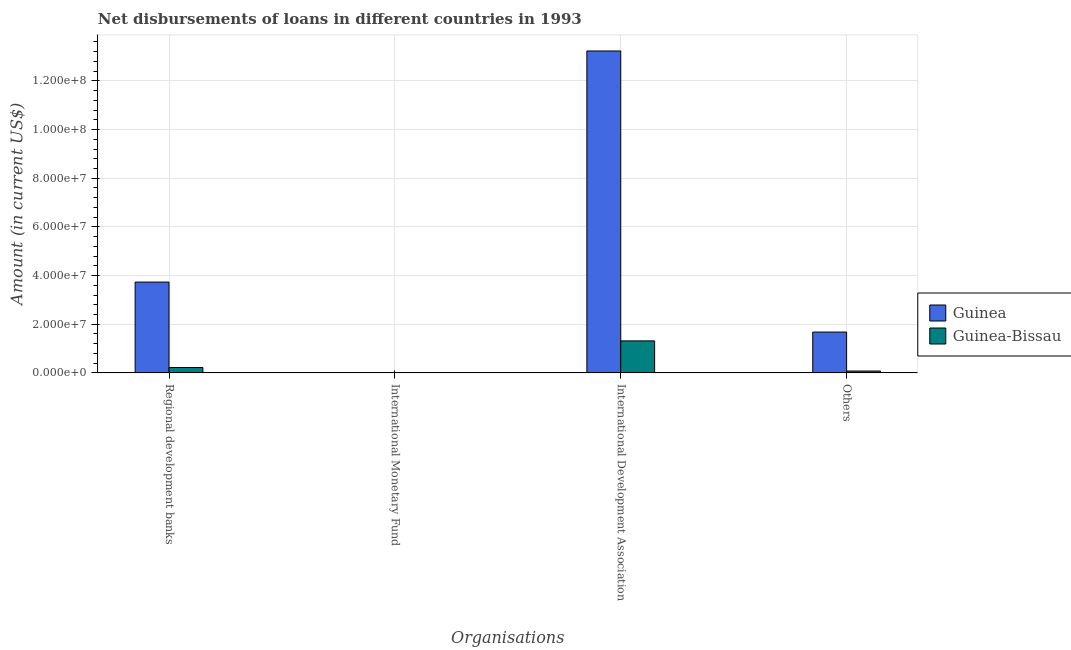How many different coloured bars are there?
Give a very brief answer. 2. How many bars are there on the 2nd tick from the left?
Provide a succinct answer. 0. What is the label of the 4th group of bars from the left?
Your response must be concise. Others. What is the amount of loan disimbursed by international development association in Guinea?
Offer a terse response. 1.32e+08. Across all countries, what is the maximum amount of loan disimbursed by regional development banks?
Your answer should be very brief. 3.73e+07. Across all countries, what is the minimum amount of loan disimbursed by regional development banks?
Offer a terse response. 2.20e+06. In which country was the amount of loan disimbursed by regional development banks maximum?
Provide a succinct answer. Guinea. What is the total amount of loan disimbursed by international monetary fund in the graph?
Your answer should be compact. 0. What is the difference between the amount of loan disimbursed by regional development banks in Guinea and that in Guinea-Bissau?
Provide a succinct answer. 3.51e+07. What is the difference between the amount of loan disimbursed by international monetary fund in Guinea and the amount of loan disimbursed by regional development banks in Guinea-Bissau?
Your answer should be very brief. -2.20e+06. What is the average amount of loan disimbursed by regional development banks per country?
Give a very brief answer. 1.98e+07. What is the difference between the amount of loan disimbursed by international development association and amount of loan disimbursed by regional development banks in Guinea-Bissau?
Provide a short and direct response. 1.09e+07. What is the ratio of the amount of loan disimbursed by other organisations in Guinea to that in Guinea-Bissau?
Ensure brevity in your answer.  22.07. Is the amount of loan disimbursed by international development association in Guinea-Bissau less than that in Guinea?
Offer a terse response. Yes. Is the difference between the amount of loan disimbursed by other organisations in Guinea and Guinea-Bissau greater than the difference between the amount of loan disimbursed by regional development banks in Guinea and Guinea-Bissau?
Your answer should be very brief. No. What is the difference between the highest and the second highest amount of loan disimbursed by regional development banks?
Give a very brief answer. 3.51e+07. What is the difference between the highest and the lowest amount of loan disimbursed by regional development banks?
Offer a very short reply. 3.51e+07. Is it the case that in every country, the sum of the amount of loan disimbursed by international monetary fund and amount of loan disimbursed by regional development banks is greater than the sum of amount of loan disimbursed by other organisations and amount of loan disimbursed by international development association?
Offer a very short reply. No. Is it the case that in every country, the sum of the amount of loan disimbursed by regional development banks and amount of loan disimbursed by international monetary fund is greater than the amount of loan disimbursed by international development association?
Offer a terse response. No. Are all the bars in the graph horizontal?
Offer a terse response. No. What is the difference between two consecutive major ticks on the Y-axis?
Ensure brevity in your answer.  2.00e+07. Where does the legend appear in the graph?
Your answer should be compact. Center right. How many legend labels are there?
Offer a very short reply. 2. How are the legend labels stacked?
Make the answer very short. Vertical. What is the title of the graph?
Your answer should be compact. Net disbursements of loans in different countries in 1993. What is the label or title of the X-axis?
Keep it short and to the point. Organisations. What is the Amount (in current US$) in Guinea in Regional development banks?
Make the answer very short. 3.73e+07. What is the Amount (in current US$) of Guinea-Bissau in Regional development banks?
Provide a succinct answer. 2.20e+06. What is the Amount (in current US$) in Guinea in International Development Association?
Offer a very short reply. 1.32e+08. What is the Amount (in current US$) of Guinea-Bissau in International Development Association?
Provide a short and direct response. 1.31e+07. What is the Amount (in current US$) of Guinea in Others?
Ensure brevity in your answer.  1.68e+07. What is the Amount (in current US$) in Guinea-Bissau in Others?
Give a very brief answer. 7.60e+05. Across all Organisations, what is the maximum Amount (in current US$) in Guinea?
Provide a succinct answer. 1.32e+08. Across all Organisations, what is the maximum Amount (in current US$) in Guinea-Bissau?
Offer a very short reply. 1.31e+07. What is the total Amount (in current US$) in Guinea in the graph?
Keep it short and to the point. 1.86e+08. What is the total Amount (in current US$) of Guinea-Bissau in the graph?
Keep it short and to the point. 1.61e+07. What is the difference between the Amount (in current US$) in Guinea in Regional development banks and that in International Development Association?
Your answer should be compact. -9.50e+07. What is the difference between the Amount (in current US$) in Guinea-Bissau in Regional development banks and that in International Development Association?
Make the answer very short. -1.09e+07. What is the difference between the Amount (in current US$) in Guinea in Regional development banks and that in Others?
Offer a terse response. 2.06e+07. What is the difference between the Amount (in current US$) in Guinea-Bissau in Regional development banks and that in Others?
Give a very brief answer. 1.44e+06. What is the difference between the Amount (in current US$) of Guinea in International Development Association and that in Others?
Provide a short and direct response. 1.16e+08. What is the difference between the Amount (in current US$) of Guinea-Bissau in International Development Association and that in Others?
Offer a terse response. 1.24e+07. What is the difference between the Amount (in current US$) in Guinea in Regional development banks and the Amount (in current US$) in Guinea-Bissau in International Development Association?
Ensure brevity in your answer.  2.42e+07. What is the difference between the Amount (in current US$) of Guinea in Regional development banks and the Amount (in current US$) of Guinea-Bissau in Others?
Ensure brevity in your answer.  3.66e+07. What is the difference between the Amount (in current US$) in Guinea in International Development Association and the Amount (in current US$) in Guinea-Bissau in Others?
Make the answer very short. 1.32e+08. What is the average Amount (in current US$) of Guinea per Organisations?
Provide a succinct answer. 4.66e+07. What is the average Amount (in current US$) in Guinea-Bissau per Organisations?
Provide a short and direct response. 4.03e+06. What is the difference between the Amount (in current US$) in Guinea and Amount (in current US$) in Guinea-Bissau in Regional development banks?
Make the answer very short. 3.51e+07. What is the difference between the Amount (in current US$) of Guinea and Amount (in current US$) of Guinea-Bissau in International Development Association?
Give a very brief answer. 1.19e+08. What is the difference between the Amount (in current US$) in Guinea and Amount (in current US$) in Guinea-Bissau in Others?
Offer a very short reply. 1.60e+07. What is the ratio of the Amount (in current US$) in Guinea in Regional development banks to that in International Development Association?
Make the answer very short. 0.28. What is the ratio of the Amount (in current US$) of Guinea-Bissau in Regional development banks to that in International Development Association?
Your answer should be compact. 0.17. What is the ratio of the Amount (in current US$) of Guinea in Regional development banks to that in Others?
Keep it short and to the point. 2.23. What is the ratio of the Amount (in current US$) in Guinea-Bissau in Regional development banks to that in Others?
Offer a terse response. 2.89. What is the ratio of the Amount (in current US$) of Guinea in International Development Association to that in Others?
Your answer should be very brief. 7.89. What is the ratio of the Amount (in current US$) of Guinea-Bissau in International Development Association to that in Others?
Ensure brevity in your answer.  17.3. What is the difference between the highest and the second highest Amount (in current US$) in Guinea?
Give a very brief answer. 9.50e+07. What is the difference between the highest and the second highest Amount (in current US$) of Guinea-Bissau?
Offer a terse response. 1.09e+07. What is the difference between the highest and the lowest Amount (in current US$) in Guinea?
Keep it short and to the point. 1.32e+08. What is the difference between the highest and the lowest Amount (in current US$) in Guinea-Bissau?
Keep it short and to the point. 1.31e+07. 